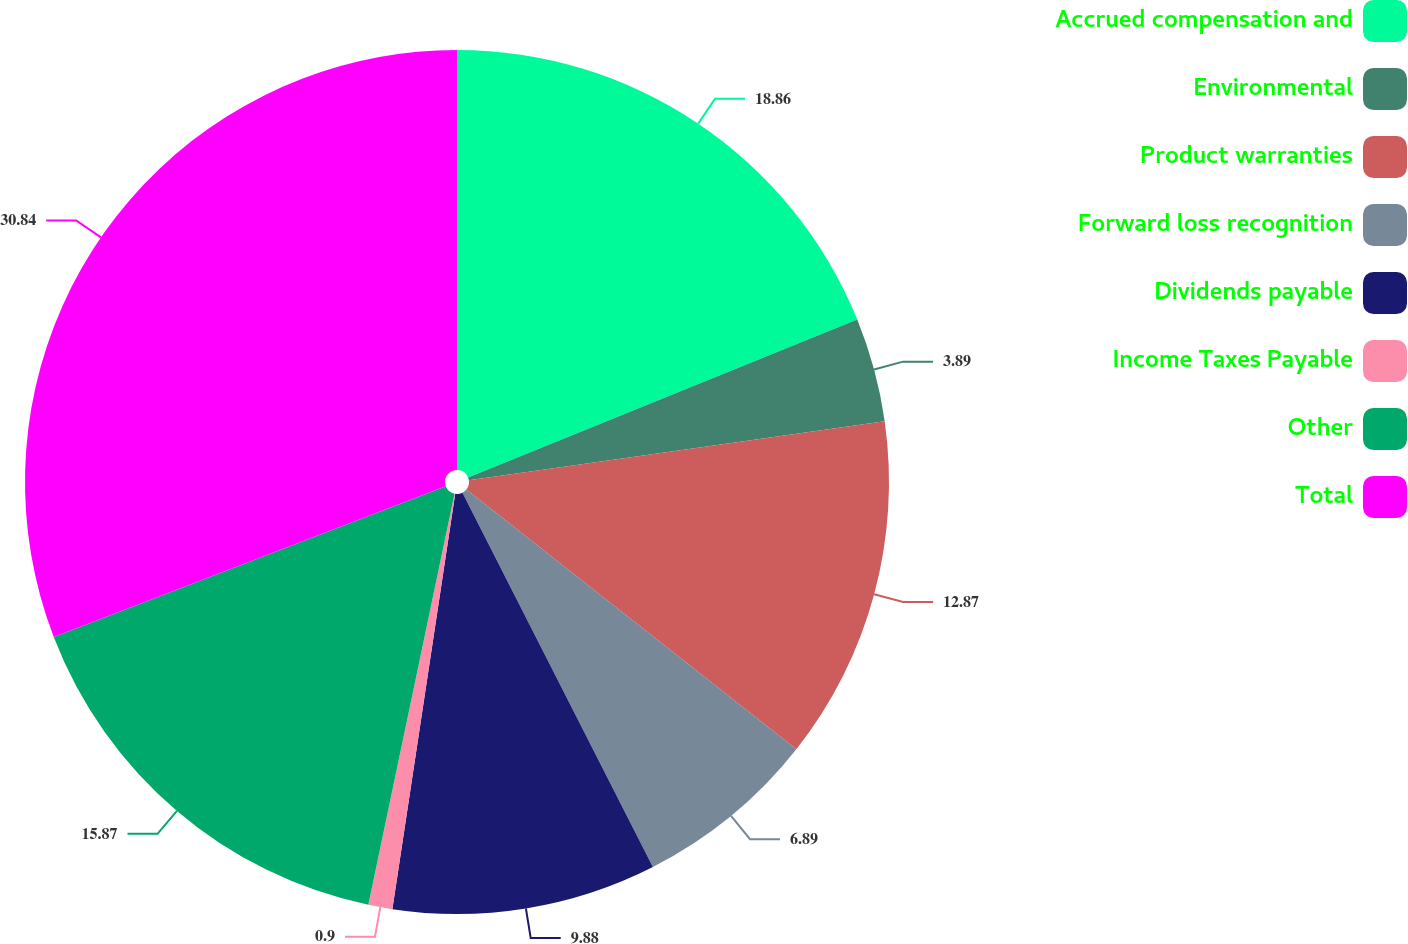Convert chart. <chart><loc_0><loc_0><loc_500><loc_500><pie_chart><fcel>Accrued compensation and<fcel>Environmental<fcel>Product warranties<fcel>Forward loss recognition<fcel>Dividends payable<fcel>Income Taxes Payable<fcel>Other<fcel>Total<nl><fcel>18.86%<fcel>3.89%<fcel>12.87%<fcel>6.89%<fcel>9.88%<fcel>0.9%<fcel>15.87%<fcel>30.84%<nl></chart> 